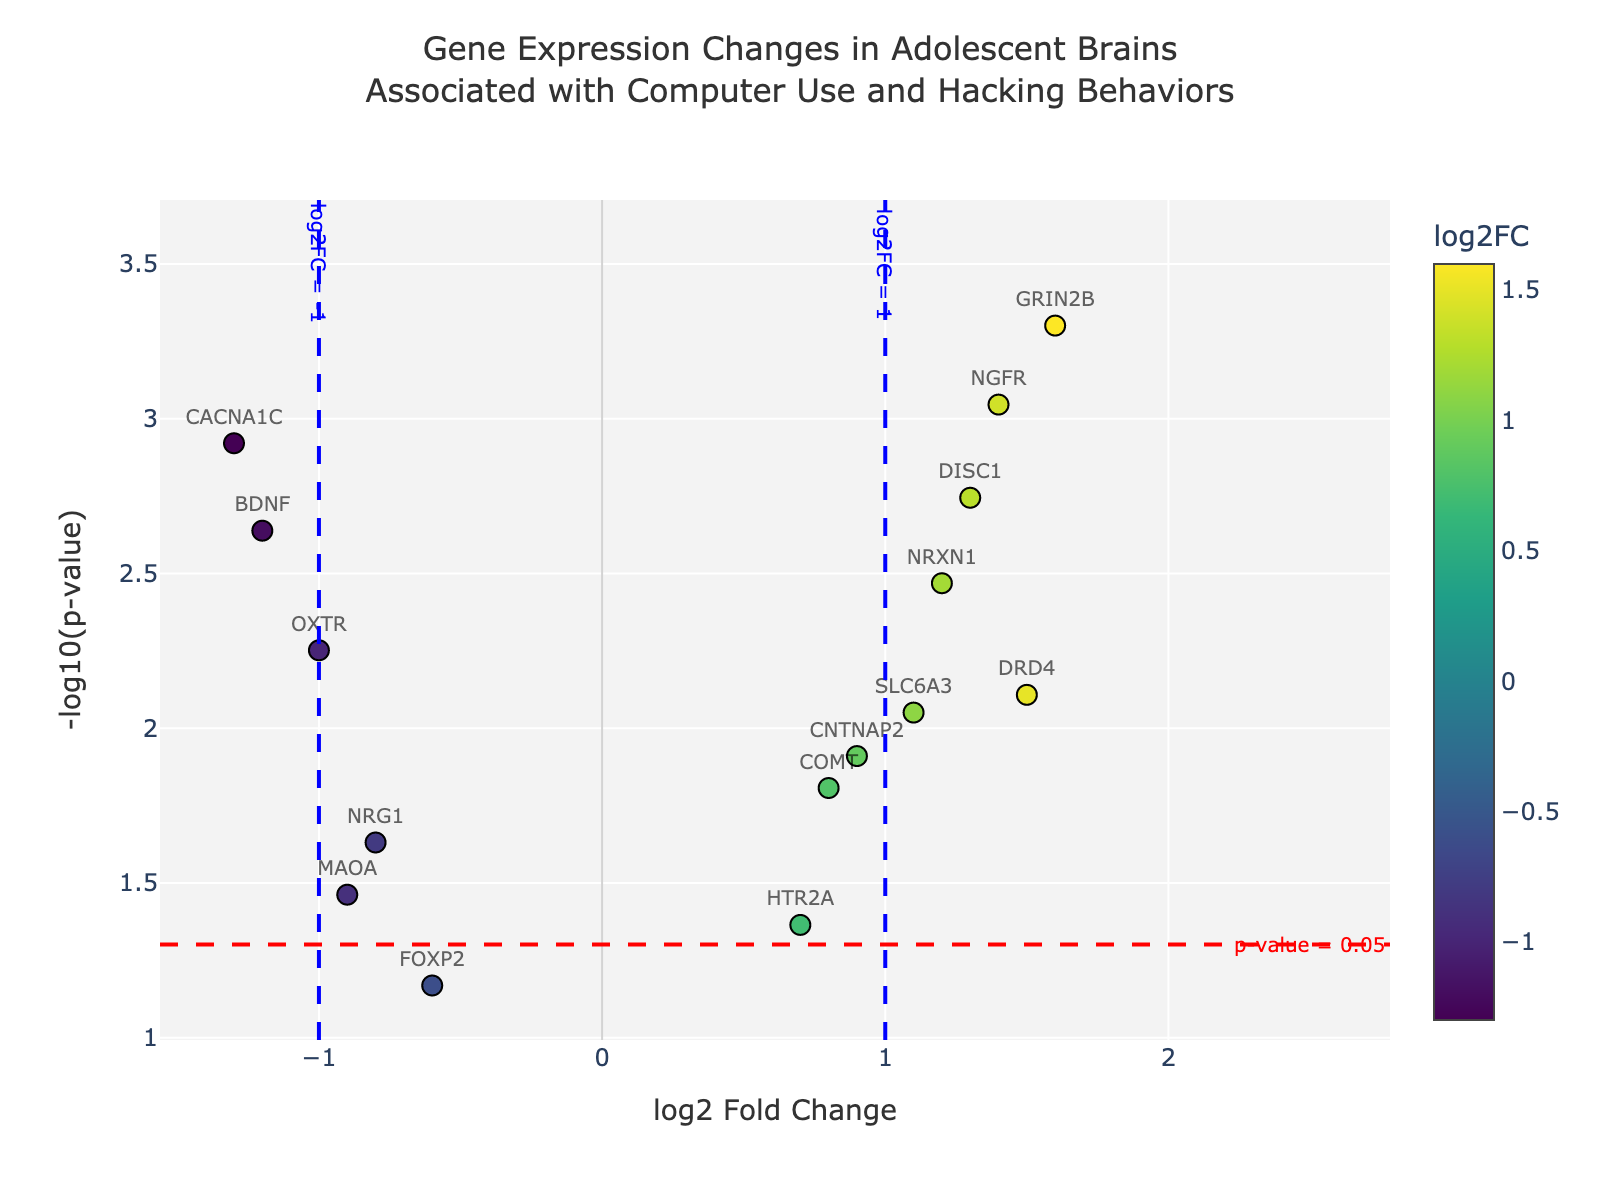what is the title of the figure? The title is visible at the top of the plot, and it gives the context of the data visualized.
Answer: Gene Expression Changes in Adolescent Brains Associated with Computer Use and Hacking Behaviors what do the x-axis labels represent? The x-axis labels represent the log2 Fold Change (log2FC), which indicates the change in gene expression levels.
Answer: log2 Fold Change how many genes have a log2 Fold Change greater than 1? Locate the data points on the right side of the x-axis at x > 1. Count the relevant data points.
Answer: 5 which gene has the most significant change in expression? Look for the data point with the highest y-value, as the y-axis represents -log10(p-value). The higher the value, the more significant the change.
Answer: GRIN2B which genes have both a log2 Fold Change of greater than 1 and a p-value less than 0.05? Identify genes that have x > 1 and are above the red dashed line indicating p-value < 0.05.
Answer: DRD4, SLC6A3, NRXN1, NGFR, DISC1 what does the red dashed horizontal line represent? This relates to the p-value threshold. The red dashed line indicates where the p-value = 0.05, beyond which genes are typically considered significant.
Answer: p-value = 0.05 which gene falls closest to the coordinate (-1, 2)? Check for the data point nearest to x = -1 and y = 2 by examining visual distance.
Answer: MAOA how is the color of each data point determined? The colors are assigned based on the log2 Fold Change values, which is also indicated by the color bar.
Answer: log2 Fold Change values which gene has the second-most significant decrease in expression? Look for the data point with the second-lowest x-coordinate and high y-coordinate values.
Answer: BDNF 